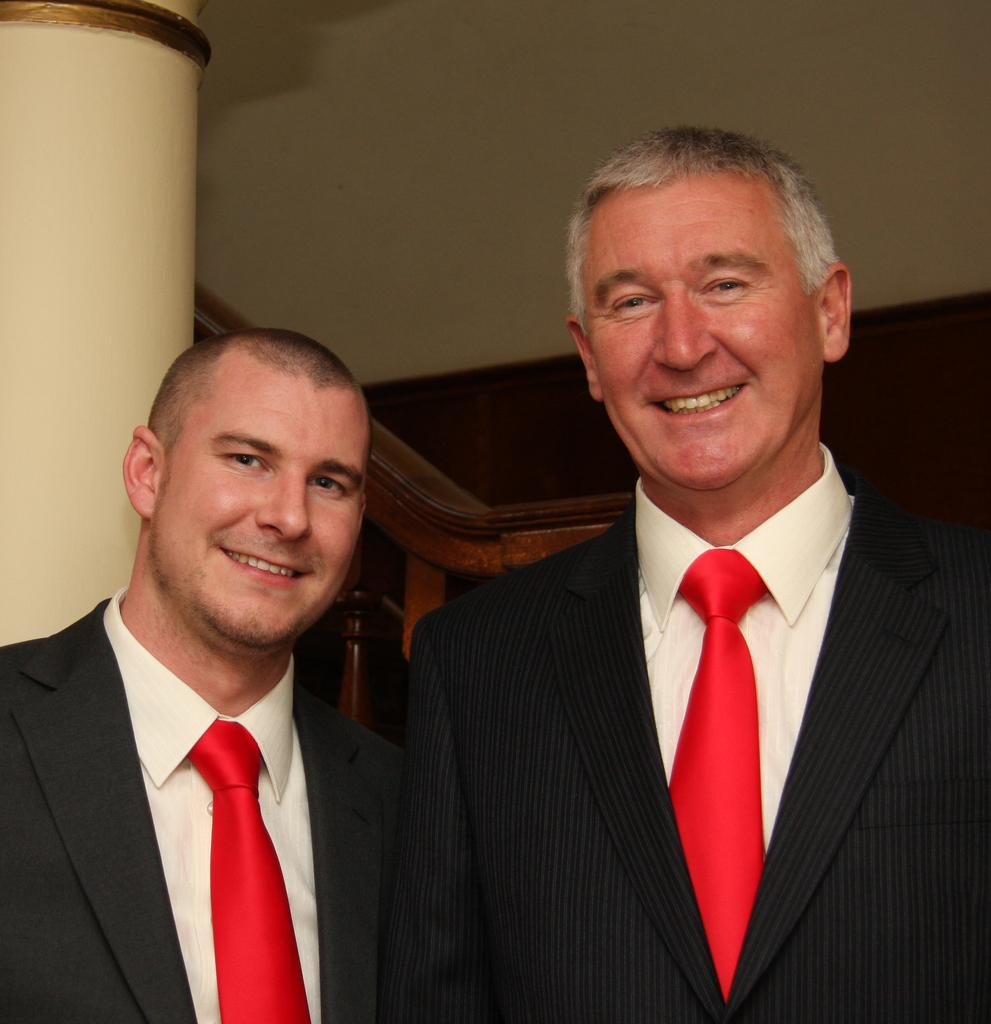How many people are in the image? There are two people standing in the center of the image. What can be seen in the background of the image? There is a pillar and a wall in the background of the image. What type of guitar is the person on the left playing in the image? There is no guitar present in the image; only two people and a background with a pillar and a wall are visible. 